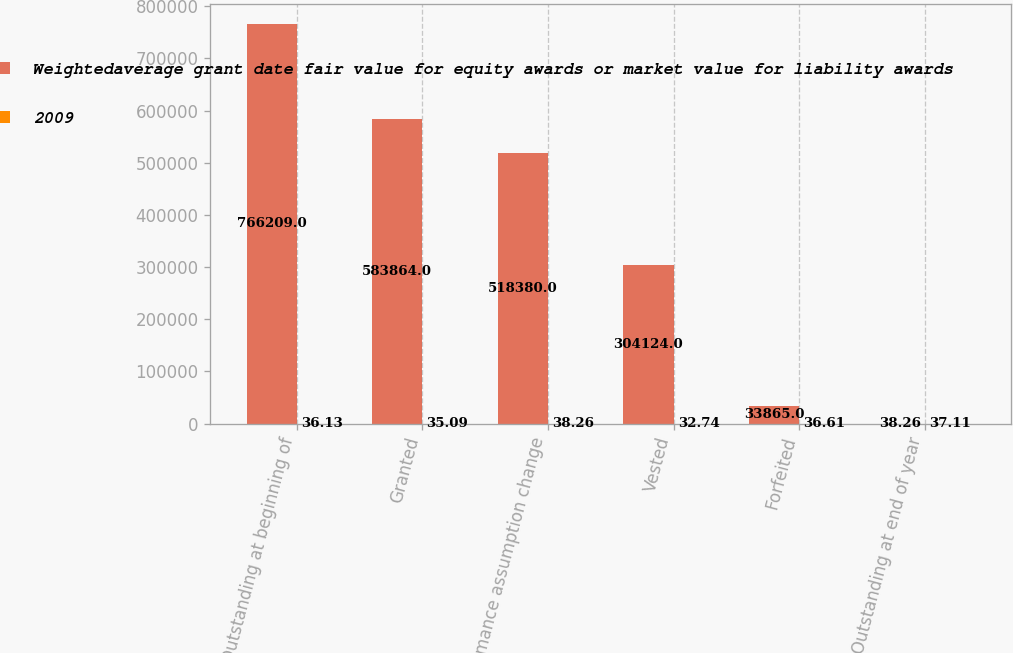Convert chart to OTSL. <chart><loc_0><loc_0><loc_500><loc_500><stacked_bar_chart><ecel><fcel>Outstanding at beginning of<fcel>Granted<fcel>Performance assumption change<fcel>Vested<fcel>Forfeited<fcel>Outstanding at end of year<nl><fcel>Weightedaverage grant date fair value for equity awards or market value for liability awards<fcel>766209<fcel>583864<fcel>518380<fcel>304124<fcel>33865<fcel>38.26<nl><fcel>2009<fcel>36.13<fcel>35.09<fcel>38.26<fcel>32.74<fcel>36.61<fcel>37.11<nl></chart> 